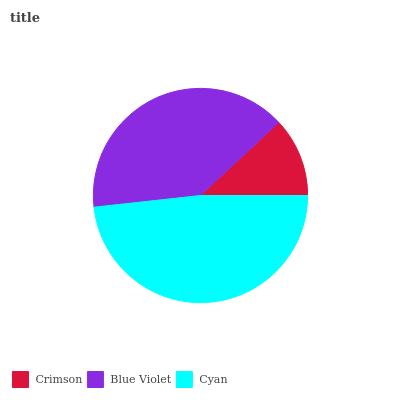Is Crimson the minimum?
Answer yes or no. Yes. Is Cyan the maximum?
Answer yes or no. Yes. Is Blue Violet the minimum?
Answer yes or no. No. Is Blue Violet the maximum?
Answer yes or no. No. Is Blue Violet greater than Crimson?
Answer yes or no. Yes. Is Crimson less than Blue Violet?
Answer yes or no. Yes. Is Crimson greater than Blue Violet?
Answer yes or no. No. Is Blue Violet less than Crimson?
Answer yes or no. No. Is Blue Violet the high median?
Answer yes or no. Yes. Is Blue Violet the low median?
Answer yes or no. Yes. Is Cyan the high median?
Answer yes or no. No. Is Cyan the low median?
Answer yes or no. No. 